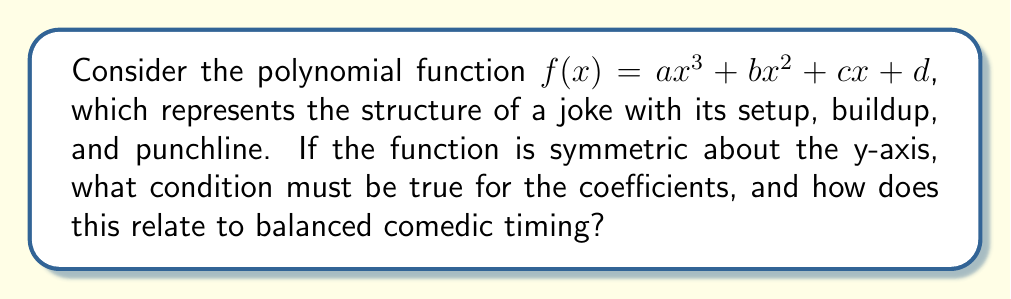Solve this math problem. Let's approach this step-by-step:

1) For a function to be symmetric about the y-axis, $f(x) = f(-x)$ for all $x$.

2) Let's apply this condition to our polynomial:
   $a(-x)^3 + b(-x)^2 + c(-x) + d = ax^3 + bx^2 + cx + d$

3) Simplify the left side:
   $-ax^3 + bx^2 - cx + d = ax^3 + bx^2 + cx + d$

4) For this equality to hold for all $x$, the coefficients of like terms must be equal:
   $-ax^3 = ax^3$
   $bx^2 = bx^2$
   $-cx = cx$
   $d = d$

5) From these equations, we can conclude:
   $a = 0$ (coefficient of $x^3$ must be zero)
   $c = 0$ (coefficient of $x$ must be zero)

6) This means our function reduces to: $f(x) = bx^2 + d$

7) In terms of comedic structure, this symmetry represents perfect balance:
   - The absence of $x^3$ and $x$ terms (a = 0, c = 0) means no "skew" in either direction.
   - The $x^2$ term (b) represents the central "arc" of the joke.
   - The constant term (d) represents the baseline or setup of the joke.

8) This balanced structure in comedy timing could be interpreted as:
   - A symmetrical setup and resolution around a central punchline.
   - Equal time given to the introduction and conclusion, with the climax at the center.
Answer: $a = 0$ and $c = 0$ 